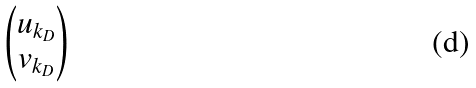Convert formula to latex. <formula><loc_0><loc_0><loc_500><loc_500>\begin{pmatrix} u _ { k _ { D } } \\ v _ { k _ { D } } \end{pmatrix}</formula> 